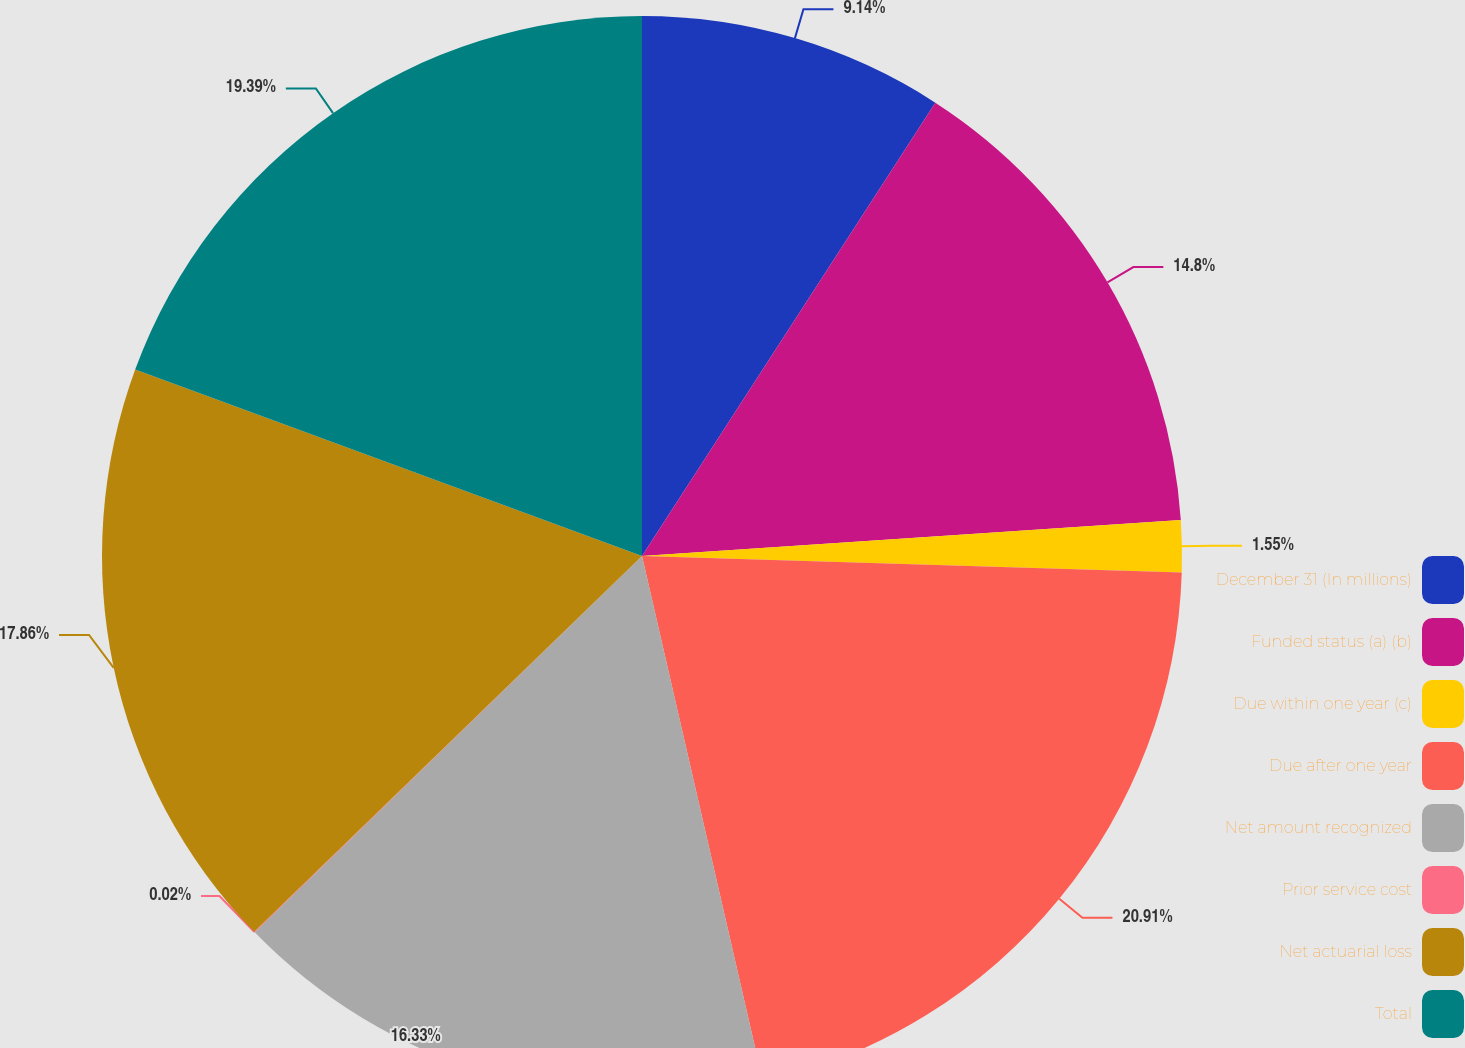Convert chart to OTSL. <chart><loc_0><loc_0><loc_500><loc_500><pie_chart><fcel>December 31 (In millions)<fcel>Funded status (a) (b)<fcel>Due within one year (c)<fcel>Due after one year<fcel>Net amount recognized<fcel>Prior service cost<fcel>Net actuarial loss<fcel>Total<nl><fcel>9.14%<fcel>14.8%<fcel>1.55%<fcel>20.91%<fcel>16.33%<fcel>0.02%<fcel>17.86%<fcel>19.39%<nl></chart> 